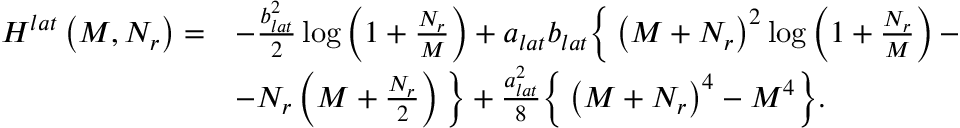Convert formula to latex. <formula><loc_0><loc_0><loc_500><loc_500>\begin{array} { r l } { H ^ { l a t } \left ( M , N _ { r } \right ) = } & { - \frac { b _ { l a t } ^ { 2 } } { 2 } \log \left ( 1 + \frac { N _ { r } } { M } \right ) + a _ { l a t } b _ { l a t } \left \{ \left ( M + N _ { r } \right ) ^ { 2 } \log \left ( 1 + \frac { N _ { r } } { M } \right ) - } \\ & { - N _ { r } \left ( M + \frac { N _ { r } } { 2 } \right ) \right \} + \frac { a _ { l a t } ^ { 2 } } { 8 } \left \{ \left ( M + N _ { r } \right ) ^ { 4 } - M ^ { 4 } \right \} . } \end{array}</formula> 